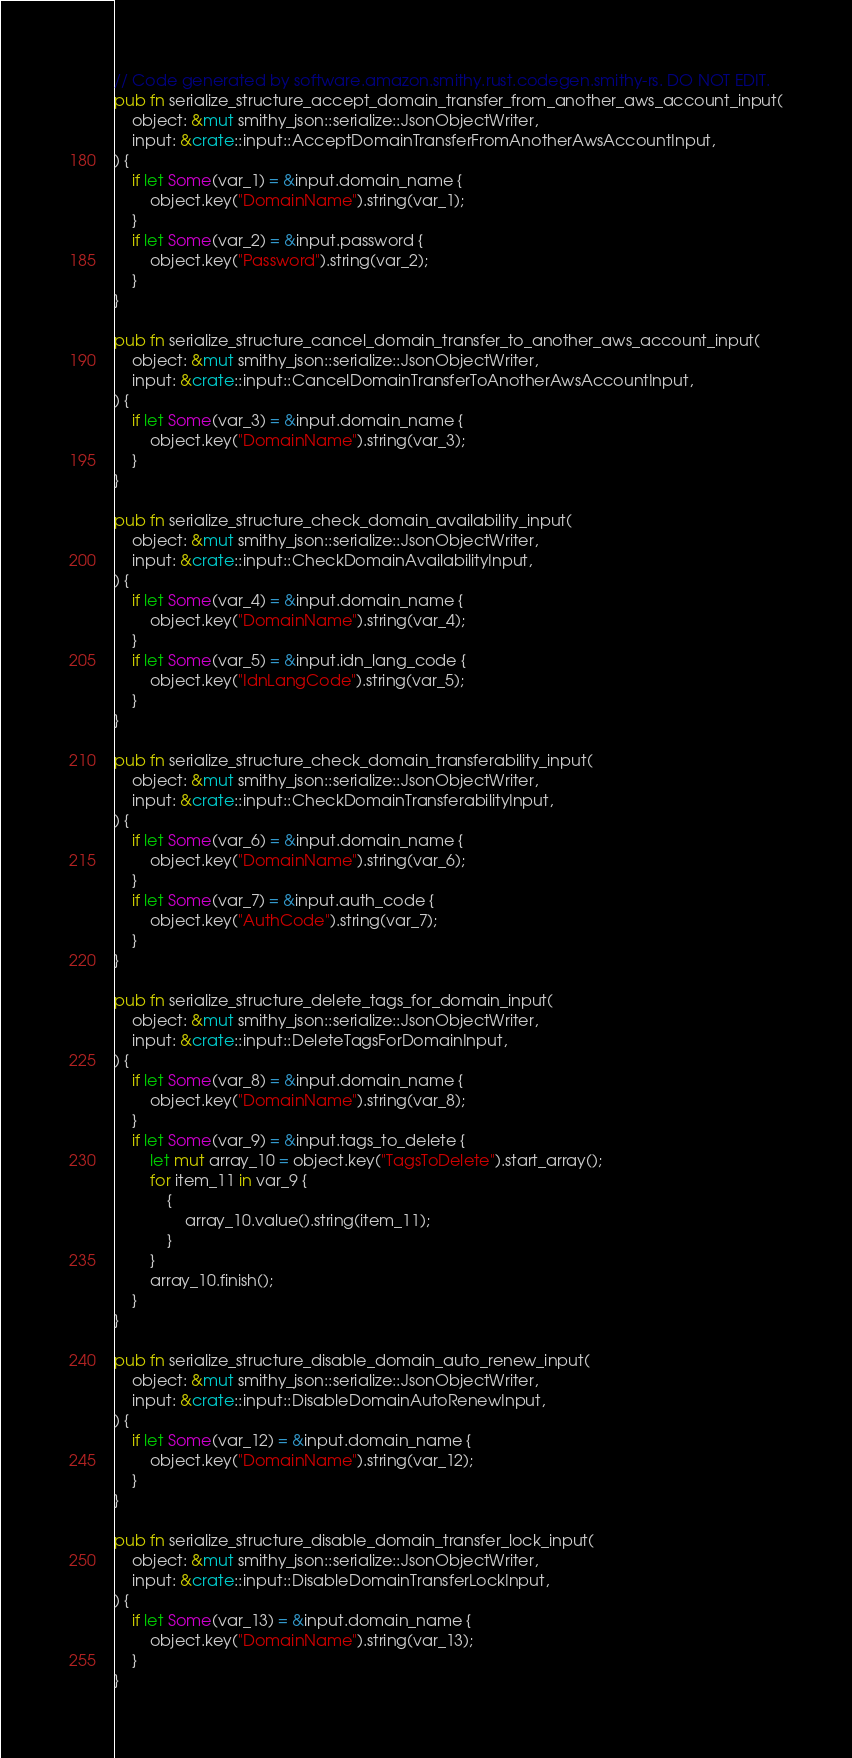<code> <loc_0><loc_0><loc_500><loc_500><_Rust_>// Code generated by software.amazon.smithy.rust.codegen.smithy-rs. DO NOT EDIT.
pub fn serialize_structure_accept_domain_transfer_from_another_aws_account_input(
    object: &mut smithy_json::serialize::JsonObjectWriter,
    input: &crate::input::AcceptDomainTransferFromAnotherAwsAccountInput,
) {
    if let Some(var_1) = &input.domain_name {
        object.key("DomainName").string(var_1);
    }
    if let Some(var_2) = &input.password {
        object.key("Password").string(var_2);
    }
}

pub fn serialize_structure_cancel_domain_transfer_to_another_aws_account_input(
    object: &mut smithy_json::serialize::JsonObjectWriter,
    input: &crate::input::CancelDomainTransferToAnotherAwsAccountInput,
) {
    if let Some(var_3) = &input.domain_name {
        object.key("DomainName").string(var_3);
    }
}

pub fn serialize_structure_check_domain_availability_input(
    object: &mut smithy_json::serialize::JsonObjectWriter,
    input: &crate::input::CheckDomainAvailabilityInput,
) {
    if let Some(var_4) = &input.domain_name {
        object.key("DomainName").string(var_4);
    }
    if let Some(var_5) = &input.idn_lang_code {
        object.key("IdnLangCode").string(var_5);
    }
}

pub fn serialize_structure_check_domain_transferability_input(
    object: &mut smithy_json::serialize::JsonObjectWriter,
    input: &crate::input::CheckDomainTransferabilityInput,
) {
    if let Some(var_6) = &input.domain_name {
        object.key("DomainName").string(var_6);
    }
    if let Some(var_7) = &input.auth_code {
        object.key("AuthCode").string(var_7);
    }
}

pub fn serialize_structure_delete_tags_for_domain_input(
    object: &mut smithy_json::serialize::JsonObjectWriter,
    input: &crate::input::DeleteTagsForDomainInput,
) {
    if let Some(var_8) = &input.domain_name {
        object.key("DomainName").string(var_8);
    }
    if let Some(var_9) = &input.tags_to_delete {
        let mut array_10 = object.key("TagsToDelete").start_array();
        for item_11 in var_9 {
            {
                array_10.value().string(item_11);
            }
        }
        array_10.finish();
    }
}

pub fn serialize_structure_disable_domain_auto_renew_input(
    object: &mut smithy_json::serialize::JsonObjectWriter,
    input: &crate::input::DisableDomainAutoRenewInput,
) {
    if let Some(var_12) = &input.domain_name {
        object.key("DomainName").string(var_12);
    }
}

pub fn serialize_structure_disable_domain_transfer_lock_input(
    object: &mut smithy_json::serialize::JsonObjectWriter,
    input: &crate::input::DisableDomainTransferLockInput,
) {
    if let Some(var_13) = &input.domain_name {
        object.key("DomainName").string(var_13);
    }
}
</code> 